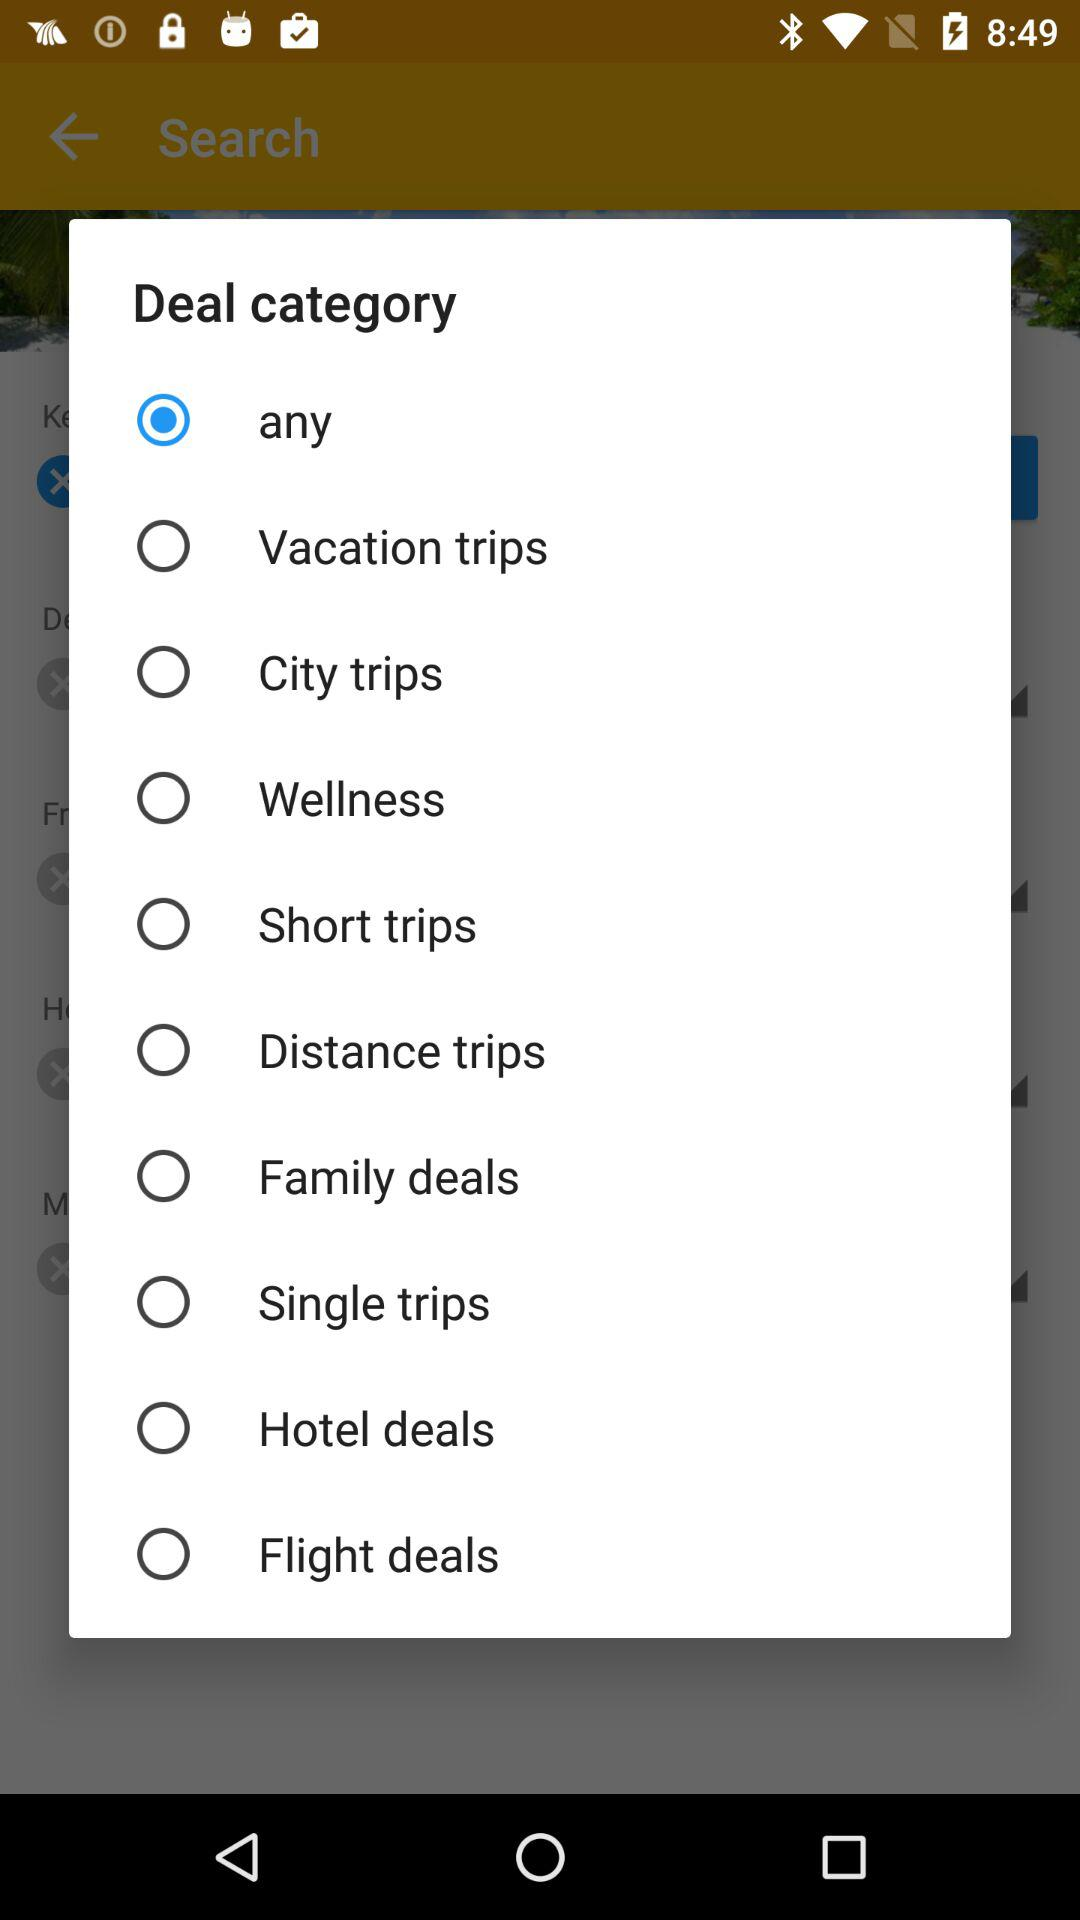Is "Wellness" selected or not? "Wellness" is not selected. 